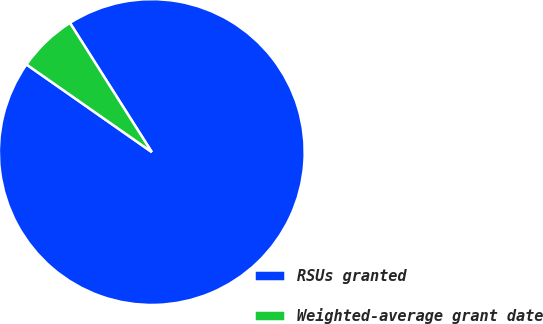Convert chart to OTSL. <chart><loc_0><loc_0><loc_500><loc_500><pie_chart><fcel>RSUs granted<fcel>Weighted-average grant date<nl><fcel>93.7%<fcel>6.3%<nl></chart> 